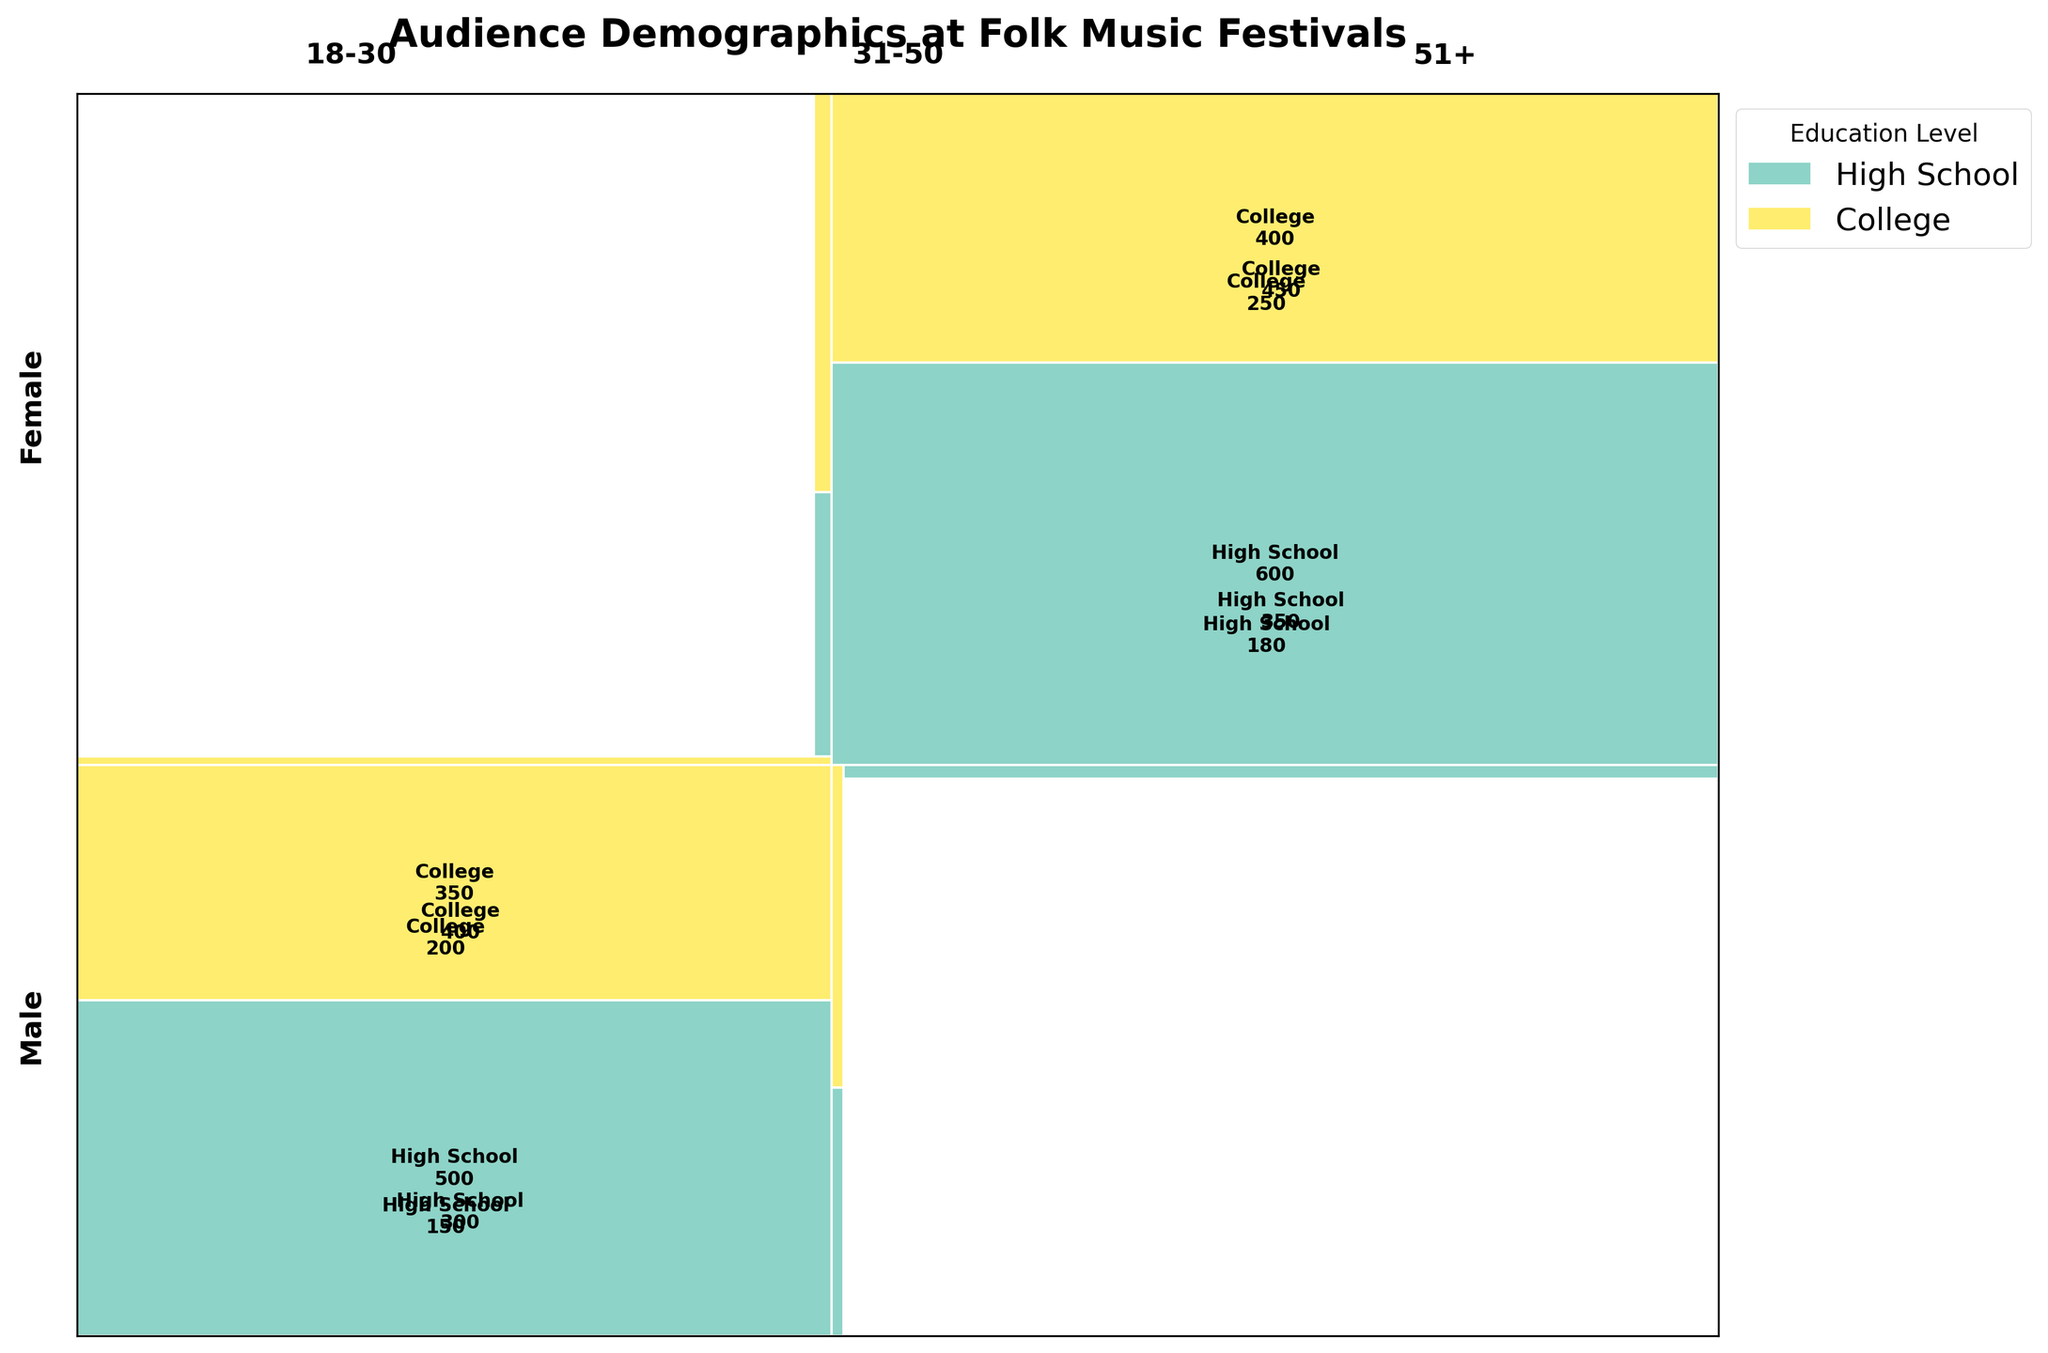Which age group has the highest festival attendance? Look at the rectangles associated with each age group. The group labeled as 51+ has the largest combined area compared to the others.
Answer: 51+ Among females with a college education, which age group has the highest festival attendance? Look at the female rectangles with a college education across age groups. The 31-50 age group has the largest rectangle.
Answer: 31-50 Which gender has a higher overall festival attendance in the 18-30 age group? Compare the total areas of the Male and Female rectangles within the 18-30 age group. The Female rectangles have a larger combined area.
Answer: Female How does the festival attendance of males with a high school education in the 31-50 age group compare to those in the 51+ age group? Check and compare the areas of the rectangles for males with high school education in both 31-50 and 51+ age groups. The 51+ age group has a larger rectangle.
Answer: 51+ What is the proportion of festival attendance by females in the 18-30 age group with a high school education? Identify the area of the rectangle for females with high school education in the 18-30 age group and divide it by the total area for the 18-30 age group. ((180 / (150 + 200 + 180 + 250))= 0.28
Answer: 0.28 Which educational level has the most festival attendance among males in the 51+ age group? Compare the two rectangles for males in the 51+ age group, one for high school and another for college education. The high school education rectangle is larger.
Answer: High School Among the 31-50 age group, do males or females with a college education have higher attendance? Compare the areas of the rectangles for males and females with a college education in the 31-50 age group. The area for females is larger.
Answer: Females What is the total festival attendance for females with high school education in all age groups? Sum the festival attendance numbers for females with high school education across all age groups: 180 (18-30) + 350 (31-50) + 600 (51+).
Answer: 1130 Compare the festival attendance of the 18-30 age group with a college education versus the 51+ age group with a college education. Evaluate the areas of the rectangles for the 18-30 and 51+ age groups with a college education and compare their festival attendance numbers. 200 (18-30) + 250 (51+).
Answer: 450 Which age group has the least attendance for males with a college education? Look at the areas of the rectangles for males with a college education across age groups and identify the smallest one. The smallest rectangle fits the 18-30 age group.
Answer: 18-30 